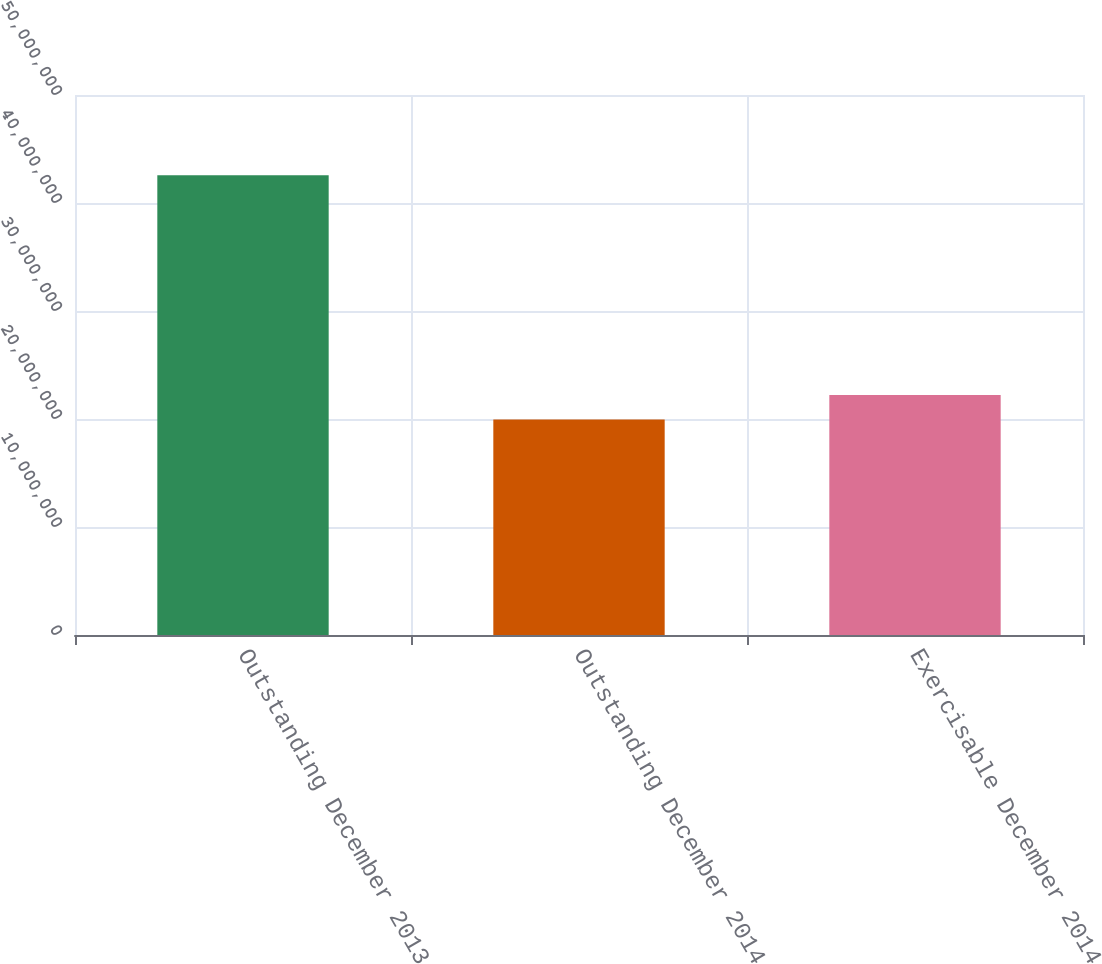Convert chart. <chart><loc_0><loc_0><loc_500><loc_500><bar_chart><fcel>Outstanding December 2013<fcel>Outstanding December 2014<fcel>Exercisable December 2014<nl><fcel>4.25652e+07<fcel>1.99553e+07<fcel>2.22163e+07<nl></chart> 